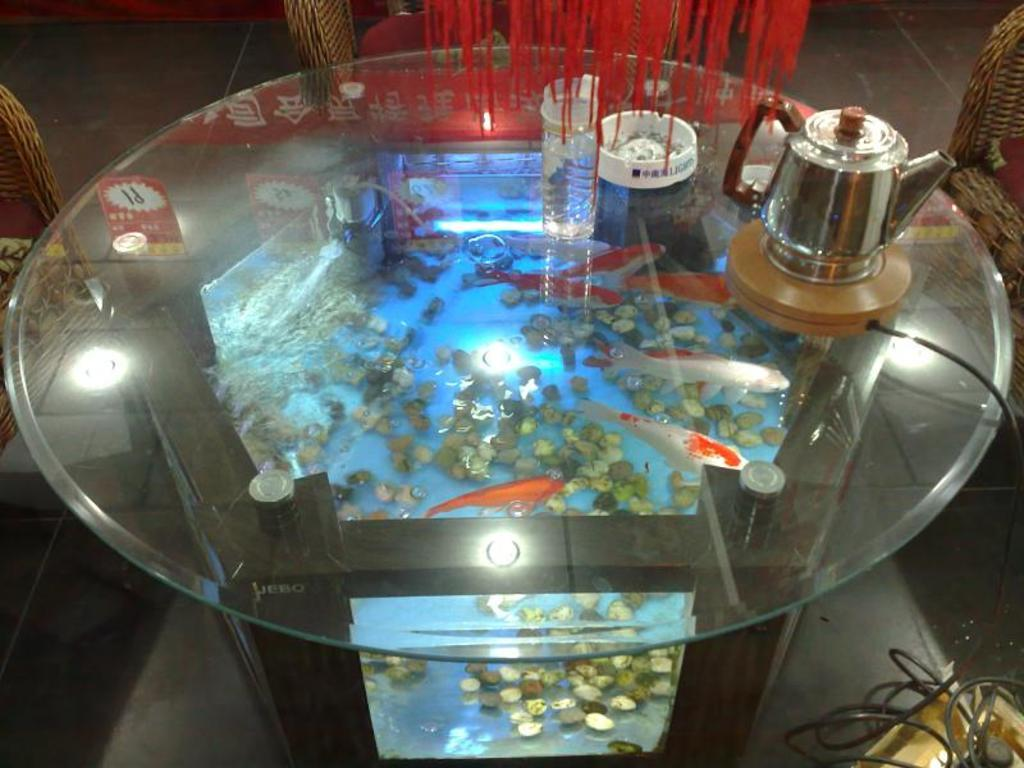What is the main piece of furniture in the image? There is a table in the center of the image. What is placed on the table? There are objects on the table. What type of seating is arranged around the table? There are chairs around the table. Can you describe anything on the right side of the image? There is a wire on the right side of the image. Is there a library in the image? No, there is no library present in the image. What type of cabbage can be seen growing on the table? There is no cabbage present in the image; it features a table with objects on it and chairs around it. 